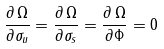Convert formula to latex. <formula><loc_0><loc_0><loc_500><loc_500>\frac { \partial \, \Omega } { \partial \sigma _ { u } } = \frac { \partial \, \Omega } { \partial \sigma _ { s } } = \frac { \partial \, \Omega } { \partial \Phi } = 0</formula> 